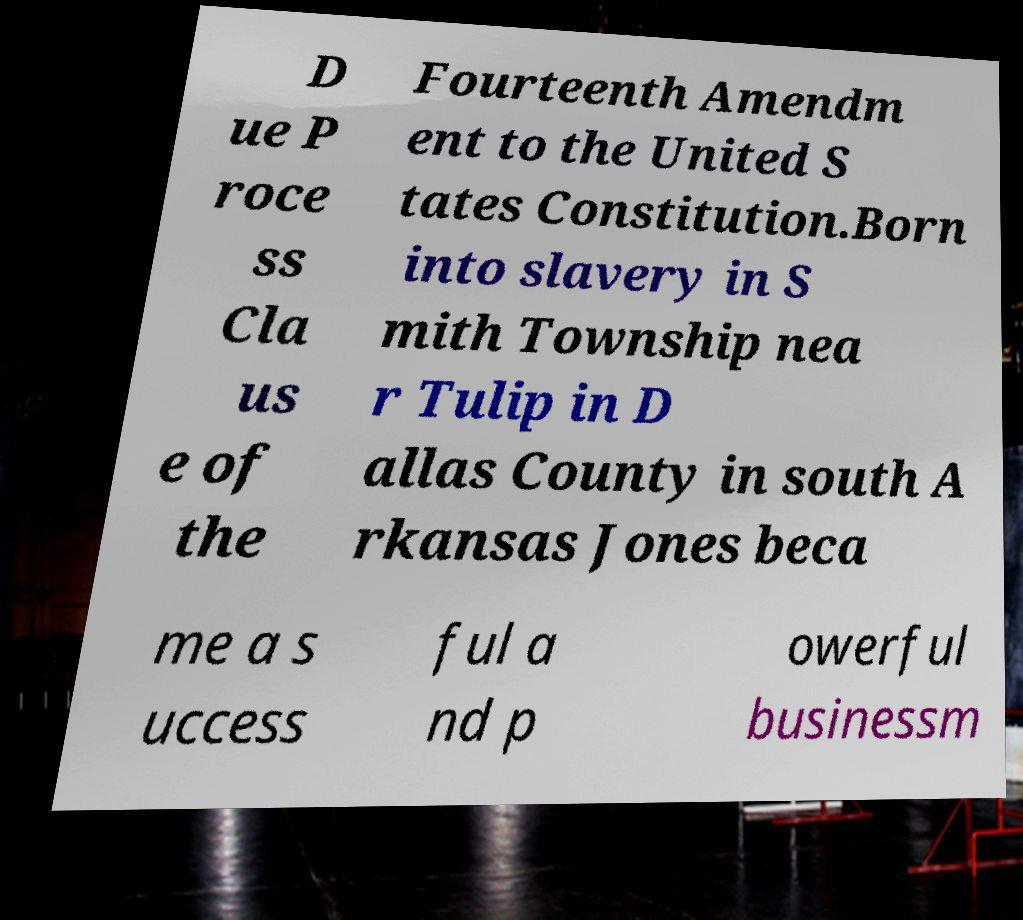Could you extract and type out the text from this image? D ue P roce ss Cla us e of the Fourteenth Amendm ent to the United S tates Constitution.Born into slavery in S mith Township nea r Tulip in D allas County in south A rkansas Jones beca me a s uccess ful a nd p owerful businessm 